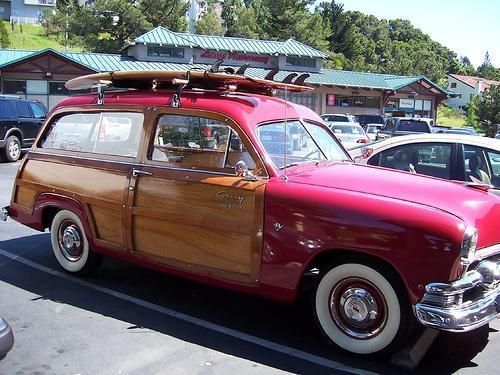How many cars are in the picture?
Give a very brief answer. 3. 